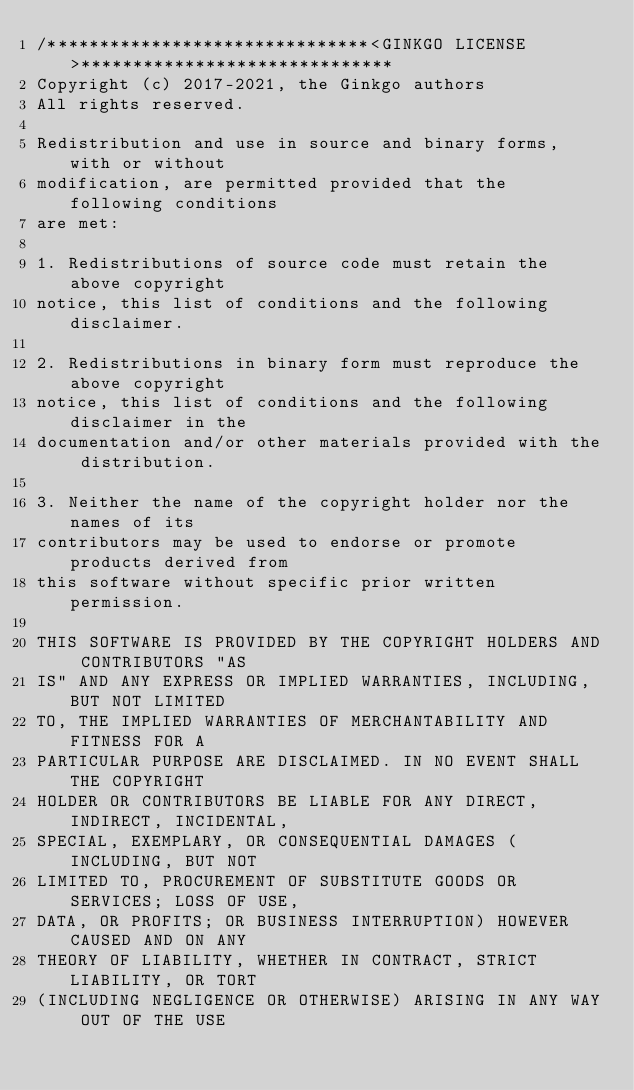Convert code to text. <code><loc_0><loc_0><loc_500><loc_500><_C++_>/*******************************<GINKGO LICENSE>******************************
Copyright (c) 2017-2021, the Ginkgo authors
All rights reserved.

Redistribution and use in source and binary forms, with or without
modification, are permitted provided that the following conditions
are met:

1. Redistributions of source code must retain the above copyright
notice, this list of conditions and the following disclaimer.

2. Redistributions in binary form must reproduce the above copyright
notice, this list of conditions and the following disclaimer in the
documentation and/or other materials provided with the distribution.

3. Neither the name of the copyright holder nor the names of its
contributors may be used to endorse or promote products derived from
this software without specific prior written permission.

THIS SOFTWARE IS PROVIDED BY THE COPYRIGHT HOLDERS AND CONTRIBUTORS "AS
IS" AND ANY EXPRESS OR IMPLIED WARRANTIES, INCLUDING, BUT NOT LIMITED
TO, THE IMPLIED WARRANTIES OF MERCHANTABILITY AND FITNESS FOR A
PARTICULAR PURPOSE ARE DISCLAIMED. IN NO EVENT SHALL THE COPYRIGHT
HOLDER OR CONTRIBUTORS BE LIABLE FOR ANY DIRECT, INDIRECT, INCIDENTAL,
SPECIAL, EXEMPLARY, OR CONSEQUENTIAL DAMAGES (INCLUDING, BUT NOT
LIMITED TO, PROCUREMENT OF SUBSTITUTE GOODS OR SERVICES; LOSS OF USE,
DATA, OR PROFITS; OR BUSINESS INTERRUPTION) HOWEVER CAUSED AND ON ANY
THEORY OF LIABILITY, WHETHER IN CONTRACT, STRICT LIABILITY, OR TORT
(INCLUDING NEGLIGENCE OR OTHERWISE) ARISING IN ANY WAY OUT OF THE USE</code> 